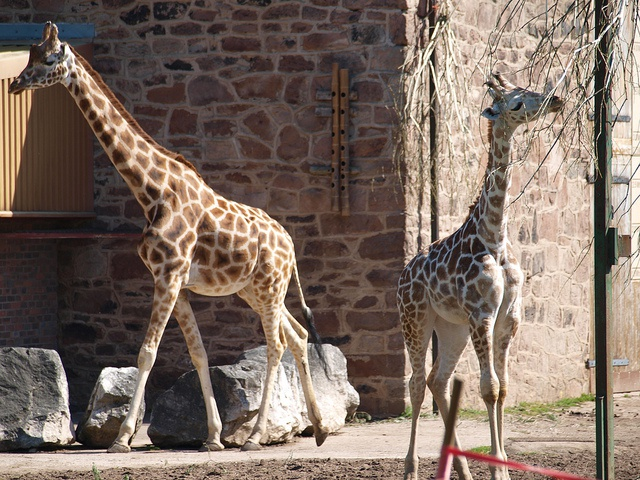Describe the objects in this image and their specific colors. I can see giraffe in black, gray, ivory, and tan tones and giraffe in black, gray, and lightgray tones in this image. 